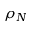Convert formula to latex. <formula><loc_0><loc_0><loc_500><loc_500>\rho _ { N }</formula> 